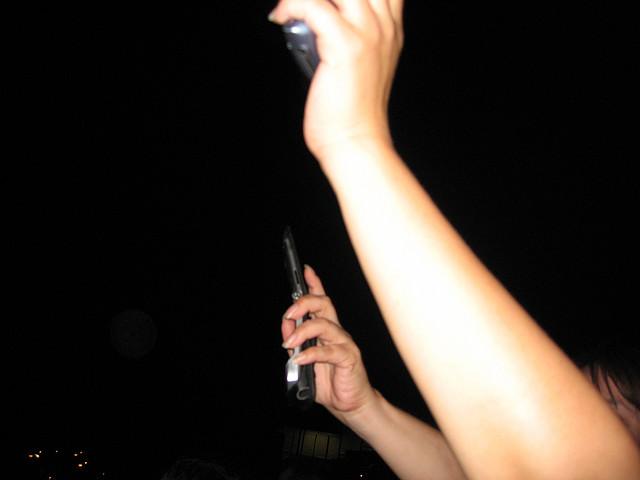What are these people holding?
Quick response, please. Cell phones. Is this photo taken with a flash?
Short answer required. Yes. Are these people at a concert?
Be succinct. Yes. 